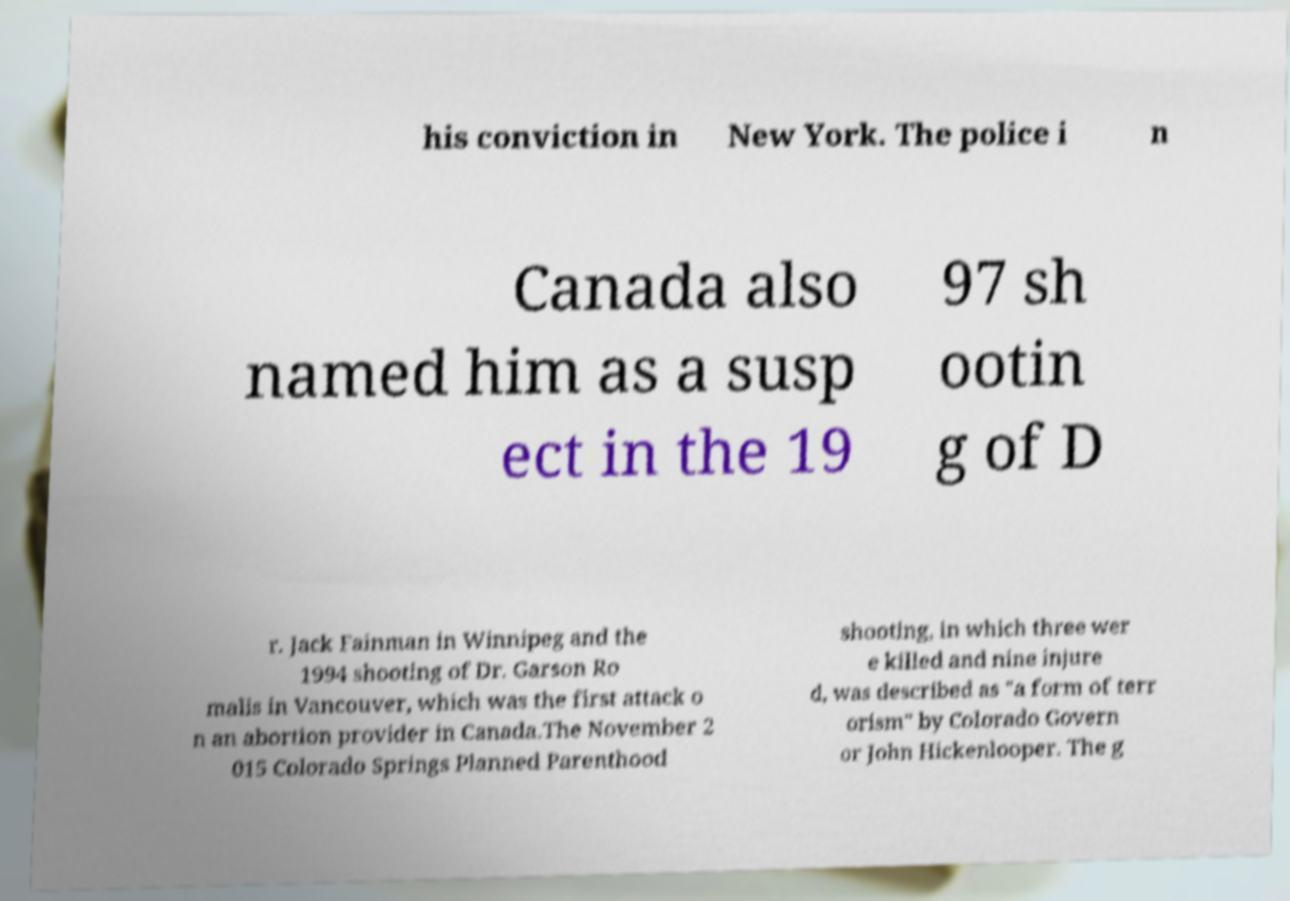Please read and relay the text visible in this image. What does it say? his conviction in New York. The police i n Canada also named him as a susp ect in the 19 97 sh ootin g of D r. Jack Fainman in Winnipeg and the 1994 shooting of Dr. Garson Ro malis in Vancouver, which was the first attack o n an abortion provider in Canada.The November 2 015 Colorado Springs Planned Parenthood shooting, in which three wer e killed and nine injure d, was described as "a form of terr orism" by Colorado Govern or John Hickenlooper. The g 